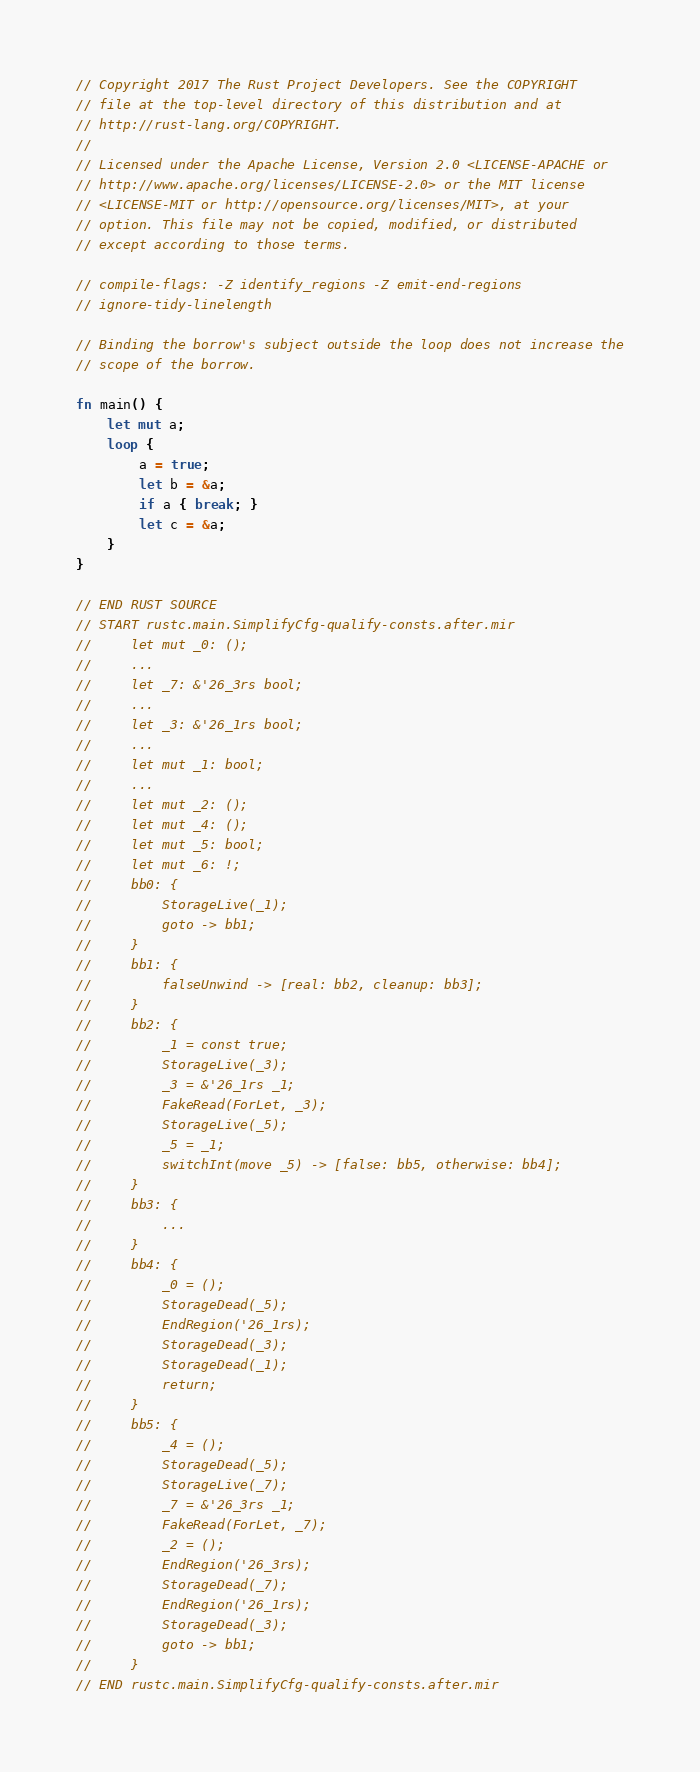Convert code to text. <code><loc_0><loc_0><loc_500><loc_500><_Rust_>// Copyright 2017 The Rust Project Developers. See the COPYRIGHT
// file at the top-level directory of this distribution and at
// http://rust-lang.org/COPYRIGHT.
//
// Licensed under the Apache License, Version 2.0 <LICENSE-APACHE or
// http://www.apache.org/licenses/LICENSE-2.0> or the MIT license
// <LICENSE-MIT or http://opensource.org/licenses/MIT>, at your
// option. This file may not be copied, modified, or distributed
// except according to those terms.

// compile-flags: -Z identify_regions -Z emit-end-regions
// ignore-tidy-linelength

// Binding the borrow's subject outside the loop does not increase the
// scope of the borrow.

fn main() {
    let mut a;
    loop {
        a = true;
        let b = &a;
        if a { break; }
        let c = &a;
    }
}

// END RUST SOURCE
// START rustc.main.SimplifyCfg-qualify-consts.after.mir
//     let mut _0: ();
//     ...
//     let _7: &'26_3rs bool;
//     ...
//     let _3: &'26_1rs bool;
//     ...
//     let mut _1: bool;
//     ...
//     let mut _2: ();
//     let mut _4: ();
//     let mut _5: bool;
//     let mut _6: !;
//     bb0: {
//         StorageLive(_1);
//         goto -> bb1;
//     }
//     bb1: {
//         falseUnwind -> [real: bb2, cleanup: bb3];
//     }
//     bb2: {
//         _1 = const true;
//         StorageLive(_3);
//         _3 = &'26_1rs _1;
//         FakeRead(ForLet, _3);
//         StorageLive(_5);
//         _5 = _1;
//         switchInt(move _5) -> [false: bb5, otherwise: bb4];
//     }
//     bb3: {
//         ...
//     }
//     bb4: {
//         _0 = ();
//         StorageDead(_5);
//         EndRegion('26_1rs);
//         StorageDead(_3);
//         StorageDead(_1);
//         return;
//     }
//     bb5: {
//         _4 = ();
//         StorageDead(_5);
//         StorageLive(_7);
//         _7 = &'26_3rs _1;
//         FakeRead(ForLet, _7);
//         _2 = ();
//         EndRegion('26_3rs);
//         StorageDead(_7);
//         EndRegion('26_1rs);
//         StorageDead(_3);
//         goto -> bb1;
//     }
// END rustc.main.SimplifyCfg-qualify-consts.after.mir
</code> 